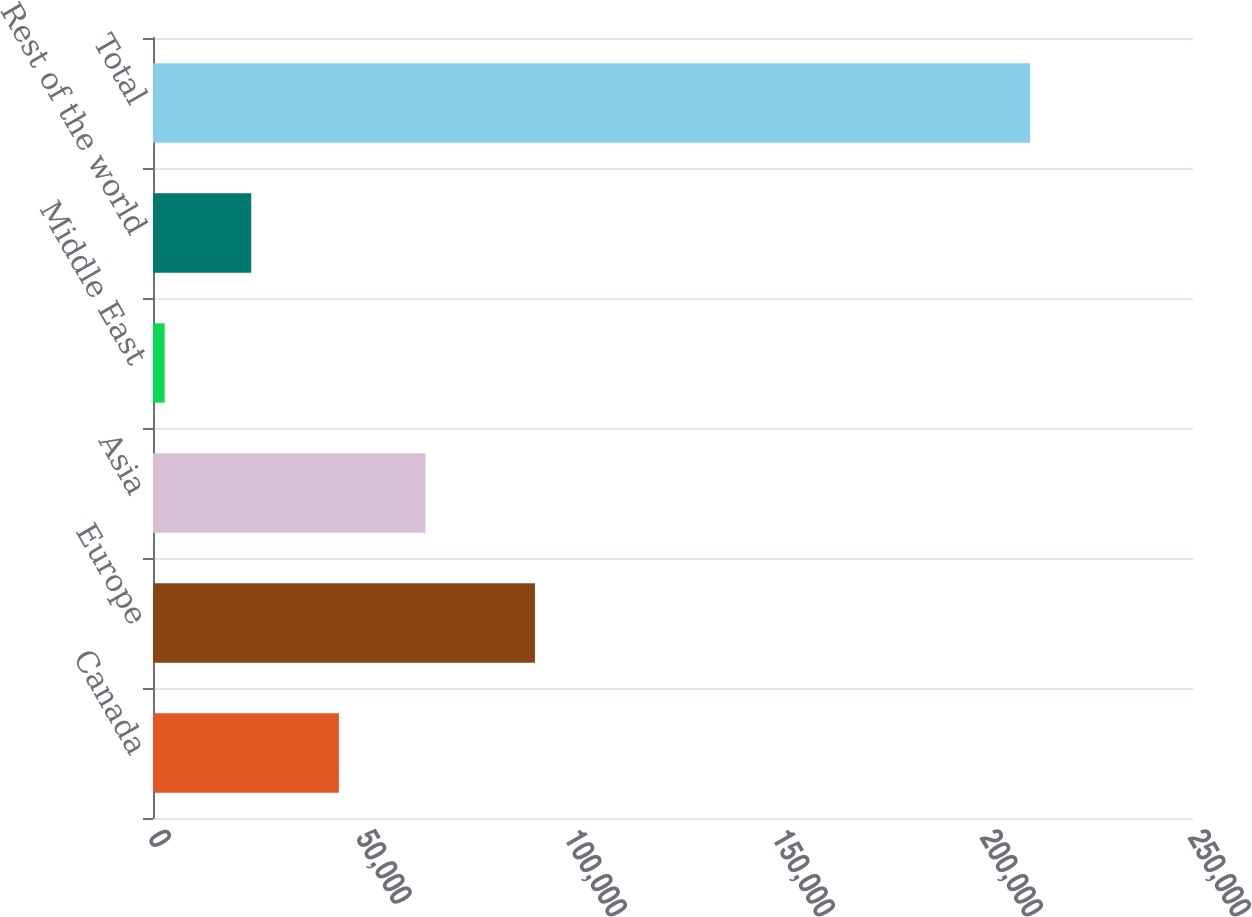<chart> <loc_0><loc_0><loc_500><loc_500><bar_chart><fcel>Canada<fcel>Europe<fcel>Asia<fcel>Middle East<fcel>Rest of the world<fcel>Total<nl><fcel>44678<fcel>91815<fcel>65483.3<fcel>2805<fcel>23610.3<fcel>210858<nl></chart> 